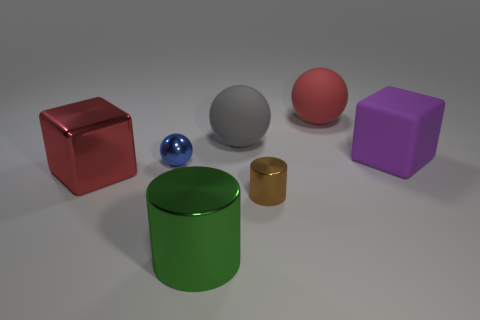There is a blue thing that is the same size as the brown metallic object; what shape is it?
Give a very brief answer. Sphere. Is the number of rubber cylinders less than the number of cubes?
Offer a terse response. Yes. What number of rubber cubes have the same size as the green object?
Your answer should be very brief. 1. What is the shape of the thing that is the same color as the big shiny cube?
Your answer should be very brief. Sphere. What is the material of the tiny blue thing?
Keep it short and to the point. Metal. There is a gray matte sphere that is to the left of the brown metallic cylinder; what size is it?
Give a very brief answer. Large. What number of purple matte things have the same shape as the red shiny thing?
Keep it short and to the point. 1. What is the shape of the big green thing that is the same material as the big red block?
Offer a very short reply. Cylinder. What number of gray objects are large matte things or big cubes?
Your answer should be very brief. 1. There is a tiny brown cylinder; are there any metal objects to the left of it?
Make the answer very short. Yes. 